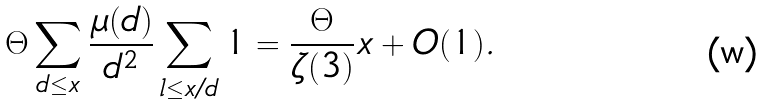<formula> <loc_0><loc_0><loc_500><loc_500>{ \Theta } \sum _ { d \leq x } \frac { \mu ( d ) } { d ^ { 2 } } \sum _ { l \leq x / d } 1 & = \frac { \Theta } { \zeta ( 3 ) } x + O ( 1 ) .</formula> 